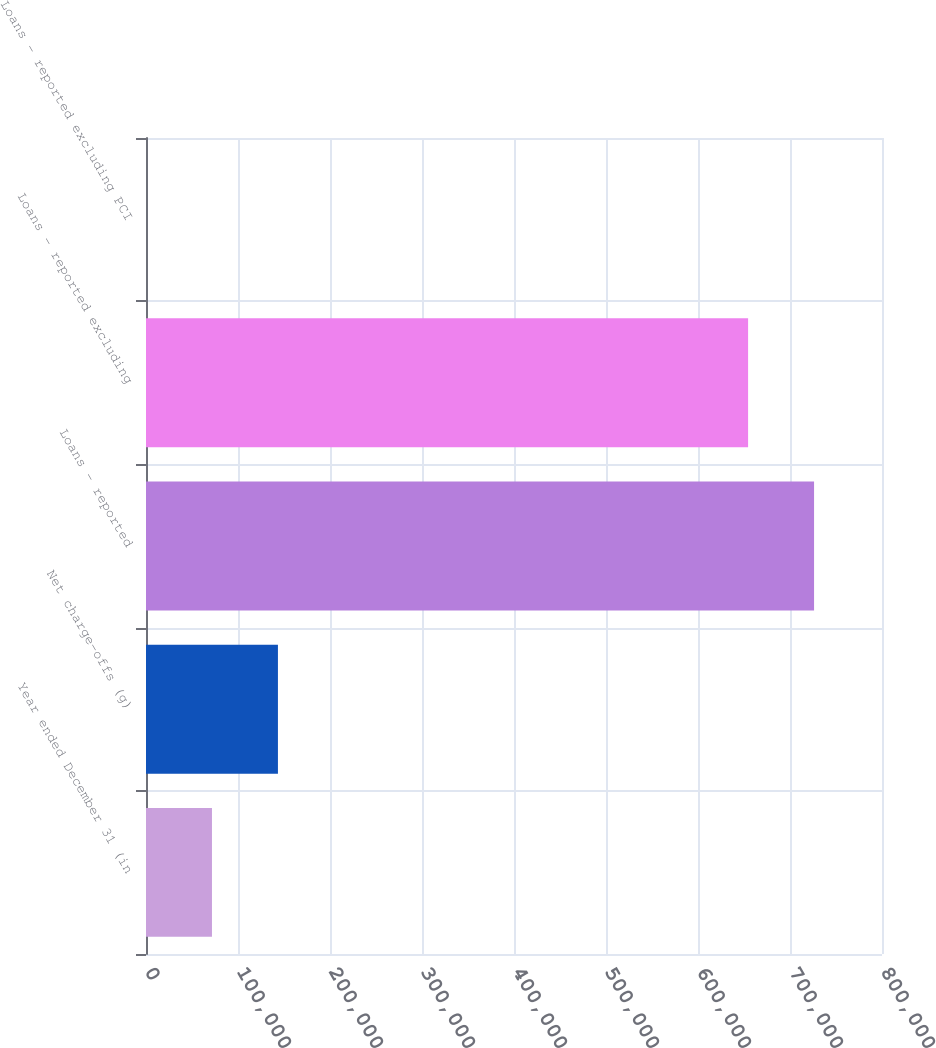<chart> <loc_0><loc_0><loc_500><loc_500><bar_chart><fcel>Year ended December 31 (in<fcel>Net charge-offs (g)<fcel>Loans - reported<fcel>Loans - reported excluding<fcel>Loans - reported excluding PCI<nl><fcel>71704.7<fcel>143408<fcel>726157<fcel>654454<fcel>1.38<nl></chart> 